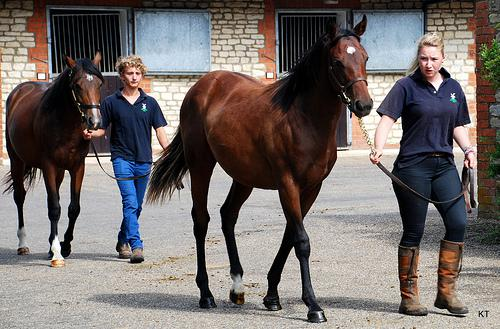Question: how many horses?
Choices:
A. One.
B. Four.
C. Two.
D. Six.
Answer with the letter. Answer: C Question: what is in the picture?
Choices:
A. Goats.
B. Two horses.
C. Pigs.
D. Llamas.
Answer with the letter. Answer: B Question: what color are the horses?
Choices:
A. Black.
B. Brown.
C. White.
D. Grey.
Answer with the letter. Answer: B Question: why are they wearing boots?
Choices:
A. Because they live in texas.
B. Because it's muddy.
C. To make a fashion statement.
D. To ride horses.
Answer with the letter. Answer: D Question: what are the people wearing?
Choices:
A. Jeans, boots, and shirt.
B. Country western gear.
C. Equestrian uniforms.
D. Rodeo clown outfits.
Answer with the letter. Answer: A Question: who is in this picture?
Choices:
A. Woman and boy.
B. Teacher and student.
C. Husband and wife.
D. Waiter and chef.
Answer with the letter. Answer: A Question: what are the people doing?
Choices:
A. Mowing grass.
B. Cleaning a barn.
C. Leading horses.
D. Harvesting crops.
Answer with the letter. Answer: C 